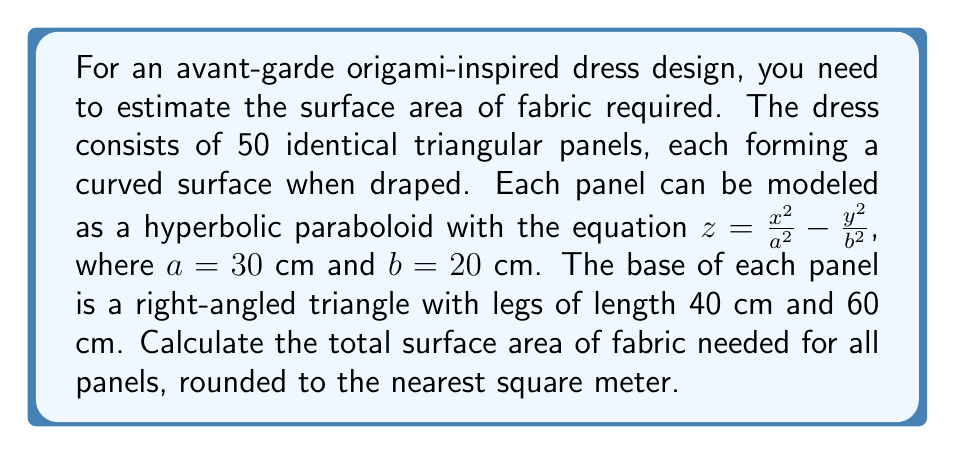Could you help me with this problem? To solve this problem, we need to follow these steps:

1) First, we need to calculate the surface area of one panel. The surface area of a hyperbolic paraboloid over a region R is given by the surface integral:

   $$A = \iint_R \sqrt{1 + (\frac{\partial z}{\partial x})^2 + (\frac{\partial z}{\partial y})^2} \, dxdy$$

2) For our hyperbolic paraboloid $z = \frac{x^2}{a^2} - \frac{y^2}{b^2}$, we have:

   $$\frac{\partial z}{\partial x} = \frac{2x}{a^2}, \quad \frac{\partial z}{\partial y} = -\frac{2y}{b^2}$$

3) Substituting these into the surface area formula:

   $$A = \iint_R \sqrt{1 + (\frac{2x}{a^2})^2 + (\frac{2y}{b^2})^2} \, dxdy$$

4) This integral is complex to evaluate analytically. However, we can use a numerical approximation. A common approximation for hyperbolic paraboloids is:

   $$A \approx 1.15 * \text{base area}$$

5) The base of each panel is a right-angled triangle with legs 40 cm and 60 cm. The area of this triangle is:

   $$A_{\text{base}} = \frac{1}{2} * 40 * 60 = 1200 \text{ cm}^2$$

6) Therefore, the approximate area of each panel is:

   $$A_{\text{panel}} \approx 1.15 * 1200 = 1380 \text{ cm}^2$$

7) There are 50 identical panels, so the total surface area is:

   $$A_{\text{total}} = 50 * 1380 = 69000 \text{ cm}^2 = 6.9 \text{ m}^2$$

8) Rounding to the nearest square meter:

   $$A_{\text{total}} \approx 7 \text{ m}^2$$
Answer: The total surface area of fabric needed for all panels, rounded to the nearest square meter, is approximately 7 m². 